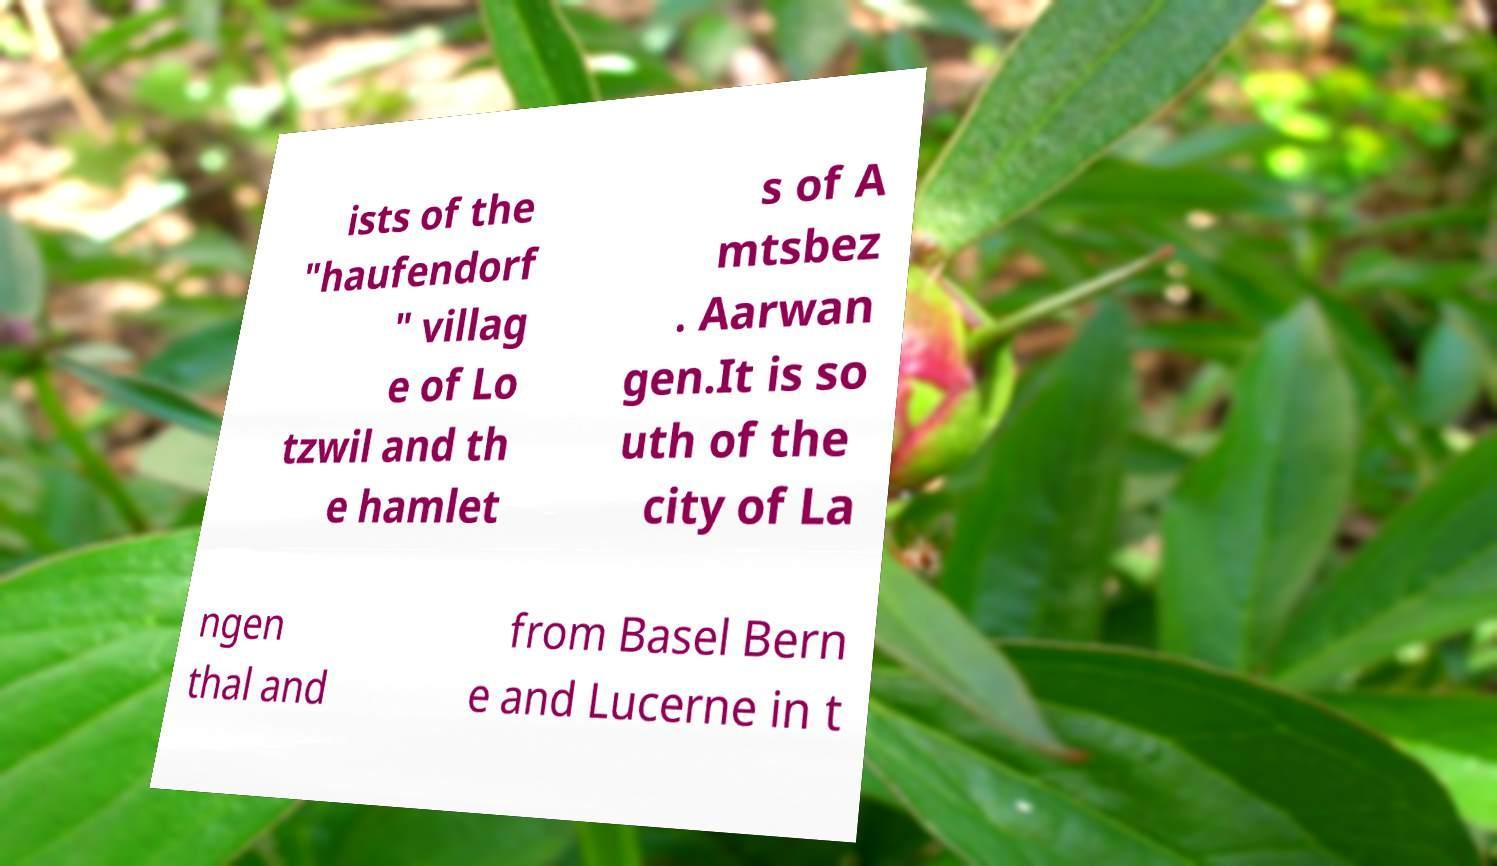Please identify and transcribe the text found in this image. ists of the "haufendorf " villag e of Lo tzwil and th e hamlet s of A mtsbez . Aarwan gen.It is so uth of the city of La ngen thal and from Basel Bern e and Lucerne in t 